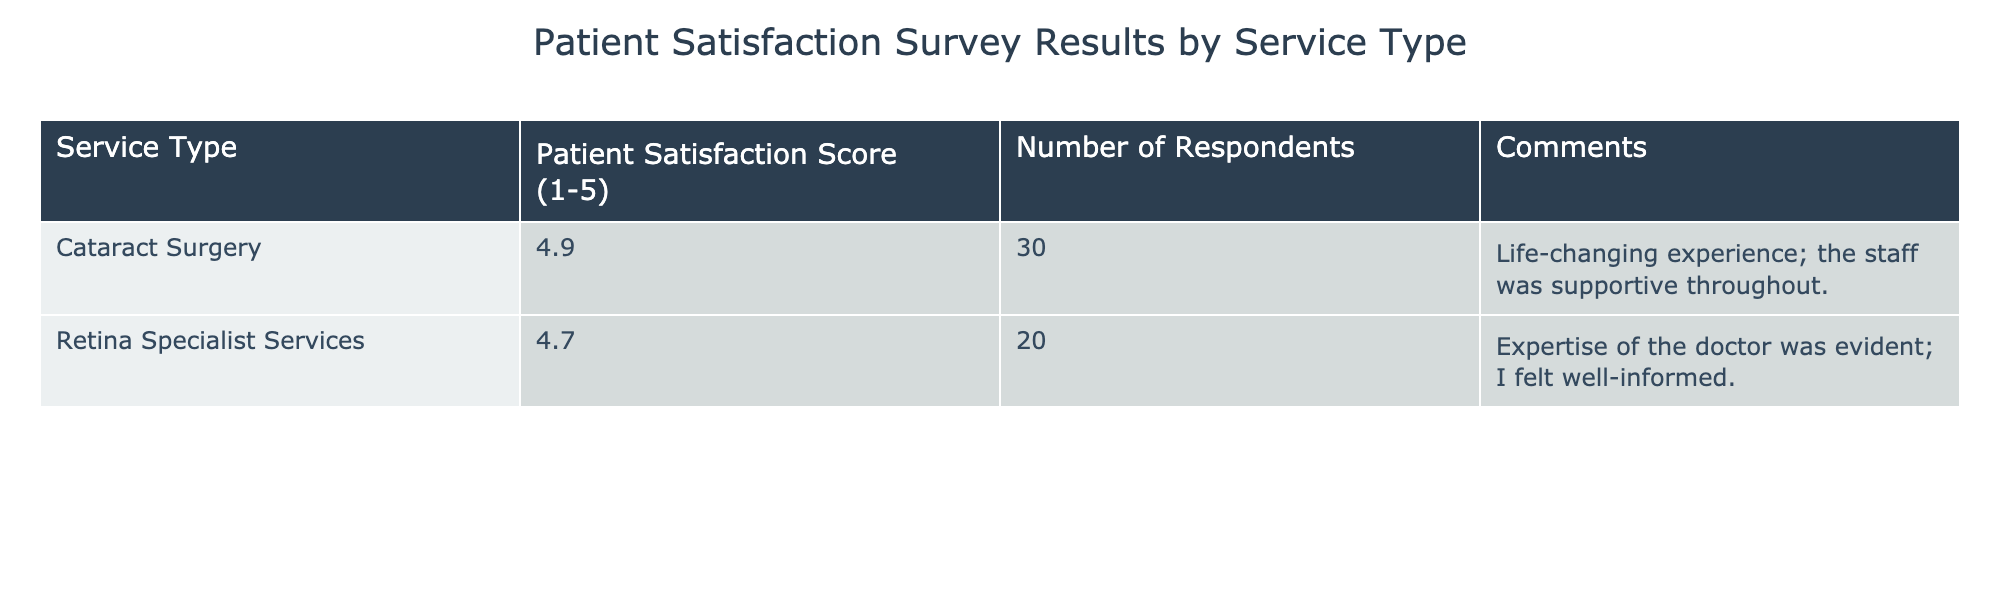What is the patient satisfaction score for Cataract Surgery? The table provides a specific entry for Cataract Surgery under the "Patient Satisfaction Score" column, which shows a value of 4.9.
Answer: 4.9 How many respondents participated in the survey for Retina Specialist Services? According to the table, the "Number of Respondents" for Retina Specialist Services is noted as 20.
Answer: 20 What is the difference in patient satisfaction scores between Cataract Surgery and Retina Specialist Services? To find the difference, subtract the satisfaction score of Retina Specialist Services (4.7) from that of Cataract Surgery (4.9). This gives us 4.9 - 4.7 = 0.2.
Answer: 0.2 What is the average patient satisfaction score across the two service types listed? To find the average score, add the satisfaction scores together (4.9 + 4.7 = 9.6) and then divide by the number of service types, which is 2: 9.6 / 2 = 4.8.
Answer: 4.8 Did more than 30 respondents participate in the Cataract Surgery survey? The table states that 30 respondents participated in the survey for Cataract Surgery. Thus, the assertion that more than 30 respondents participated is false.
Answer: No 